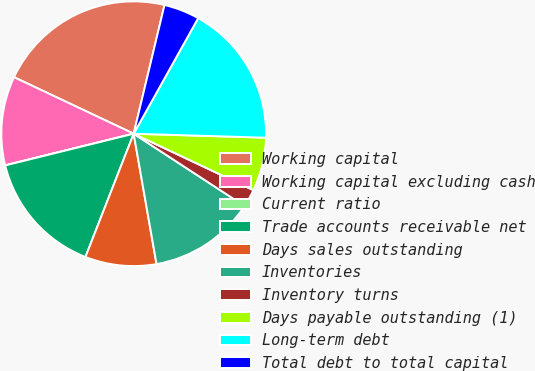<chart> <loc_0><loc_0><loc_500><loc_500><pie_chart><fcel>Working capital<fcel>Working capital excluding cash<fcel>Current ratio<fcel>Trade accounts receivable net<fcel>Days sales outstanding<fcel>Inventories<fcel>Inventory turns<fcel>Days payable outstanding (1)<fcel>Long-term debt<fcel>Total debt to total capital<nl><fcel>21.72%<fcel>10.87%<fcel>0.01%<fcel>15.21%<fcel>8.7%<fcel>13.04%<fcel>2.19%<fcel>6.53%<fcel>17.38%<fcel>4.36%<nl></chart> 